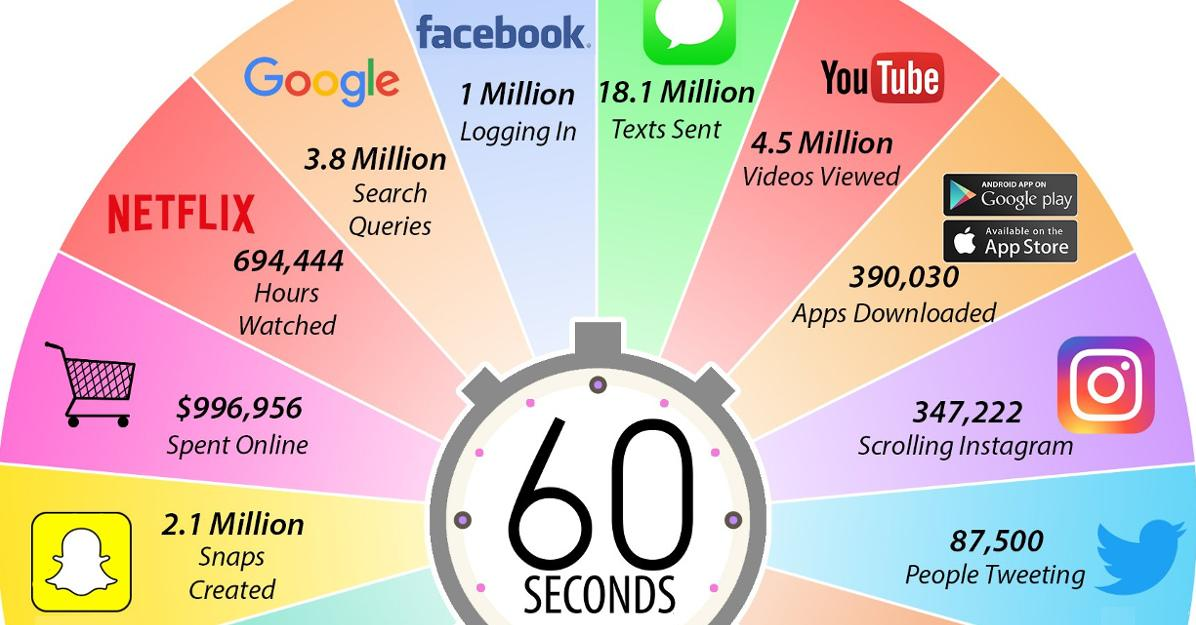Outline some significant characteristics in this image. It is estimated that, on average, approximately 3.8 million Google search queries were made per 60 seconds. The amount of money spent on online shopping per 60 seconds is approximately $996,956. It is estimated that approximately 1 million people log on to Facebook every 60 seconds. In 60 seconds, YouTube viewers watched approximately 4.5 million videos. Approximately 87,500 tweets were made per 60 seconds. 